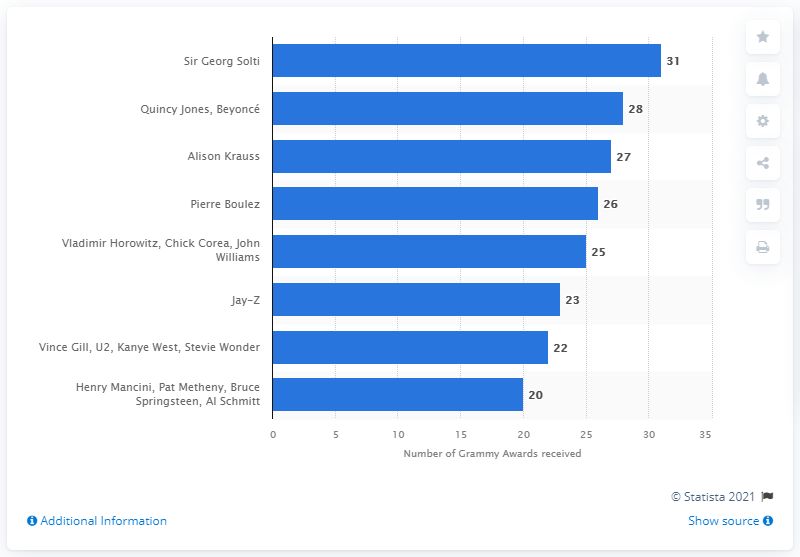List a handful of essential elements in this visual. Sir Georg Solti has won a total of 31 Grammy Awards. The average number of Grammy awards received by artists is greater than the number of Grammy awards received by Jay-Z. Sir Georg Solti is the most Grammy Award-winning individual of all time. As of 2021, Sir Georg Solti holds the record for the most Grammy Awards of all time. 